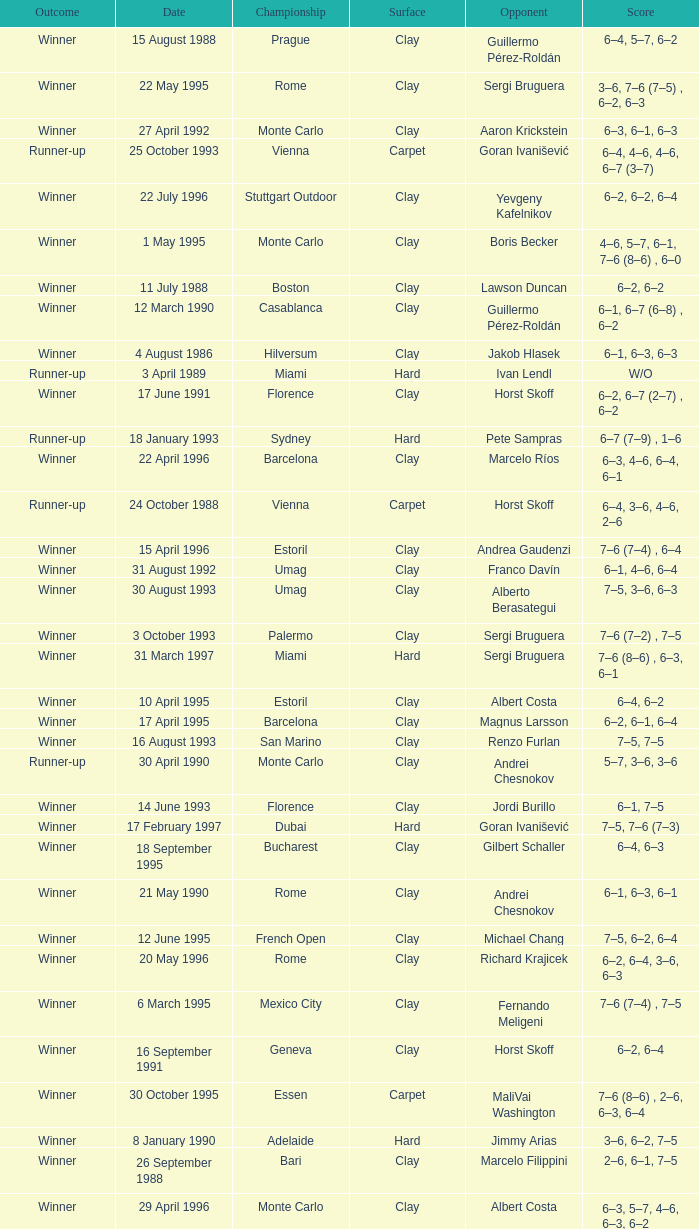Who is the opponent on 18 january 1993? Pete Sampras. 